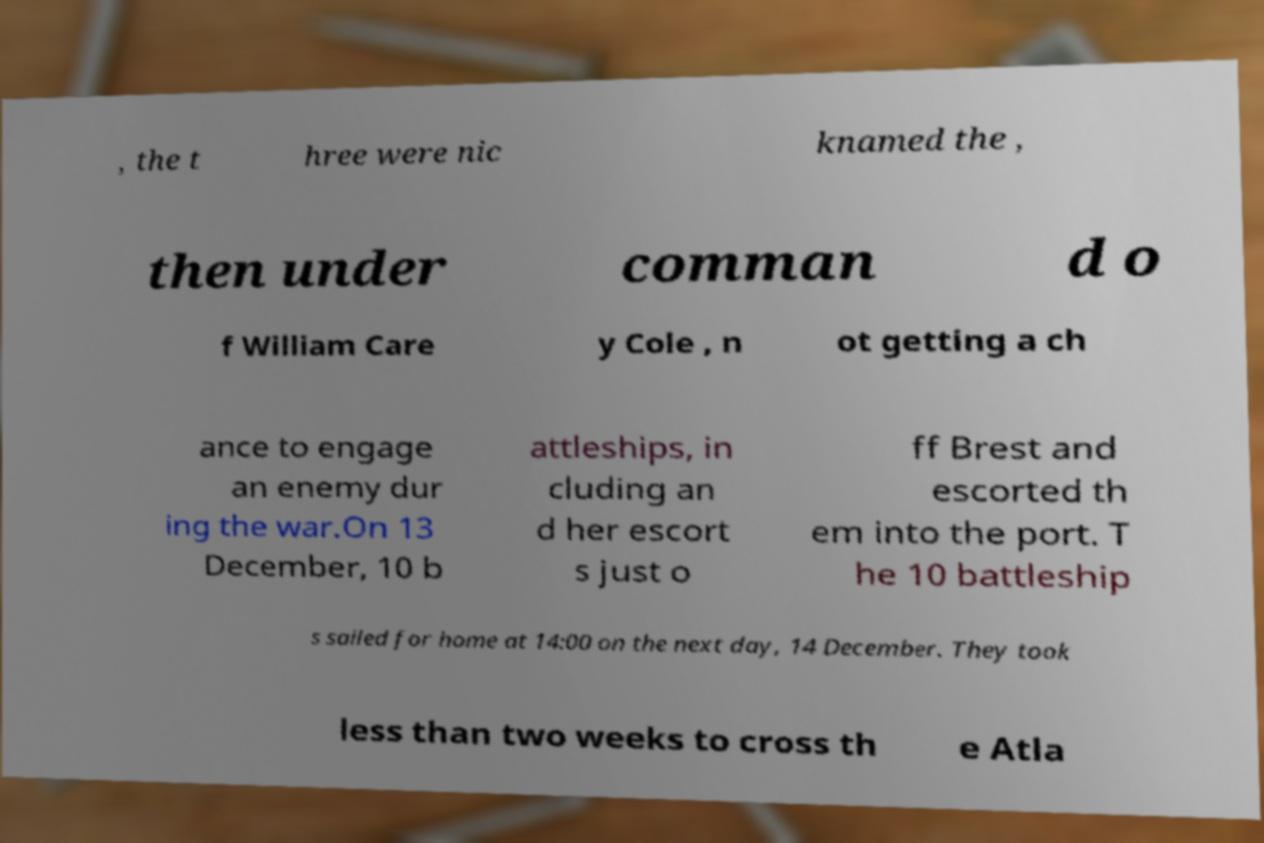There's text embedded in this image that I need extracted. Can you transcribe it verbatim? , the t hree were nic knamed the , then under comman d o f William Care y Cole , n ot getting a ch ance to engage an enemy dur ing the war.On 13 December, 10 b attleships, in cluding an d her escort s just o ff Brest and escorted th em into the port. T he 10 battleship s sailed for home at 14:00 on the next day, 14 December. They took less than two weeks to cross th e Atla 